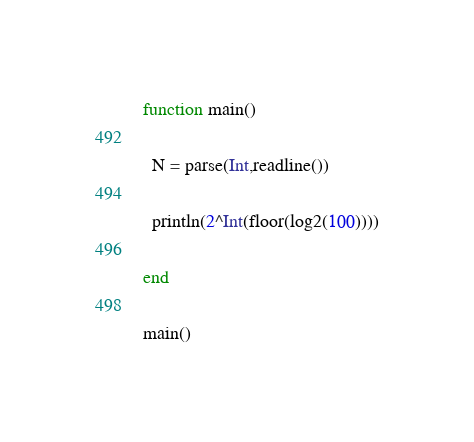Convert code to text. <code><loc_0><loc_0><loc_500><loc_500><_Julia_>function main()
  
  N = parse(Int,readline())
  
  println(2^Int(floor(log2(100))))
  
end

main()</code> 